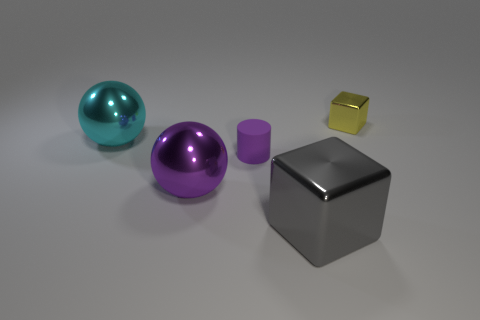What shape is the large thing that is the same color as the rubber cylinder?
Your answer should be very brief. Sphere. Do the tiny cube and the large sphere that is in front of the small matte object have the same color?
Make the answer very short. No. There is a purple rubber cylinder that is to the right of the cyan object; is it the same size as the big cyan metal ball?
Offer a very short reply. No. There is another thing that is the same shape as the tiny metal thing; what is its material?
Ensure brevity in your answer.  Metal. Is the shape of the cyan thing the same as the large purple metallic object?
Provide a succinct answer. Yes. What number of gray metal things are in front of the large sphere behind the small purple matte thing?
Ensure brevity in your answer.  1. There is a big purple object that is the same material as the large cube; what is its shape?
Provide a short and direct response. Sphere. How many cyan objects are big objects or big shiny balls?
Provide a short and direct response. 1. There is a metallic block that is behind the metallic block left of the small cube; are there any purple balls to the left of it?
Your answer should be compact. Yes. Is the number of large metal cubes less than the number of tiny purple metal cylinders?
Provide a short and direct response. No. 